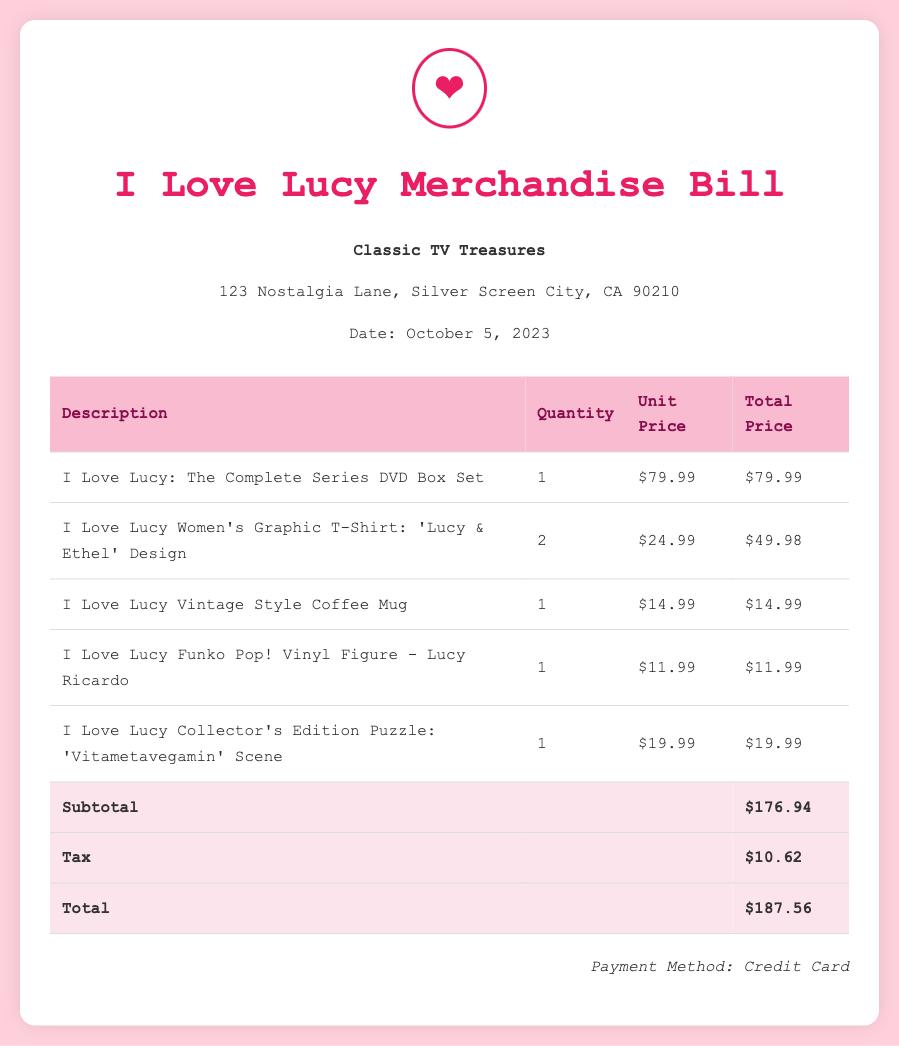What is the name of the store? The name of the store is displayed prominently in the document, suggesting its identity as a merchandise provider.
Answer: Classic TV Treasures What is the date of the bill? The date is indicated in the store information section of the bill.
Answer: October 5, 2023 How many I Love Lucy T-shirts were purchased? The quantity of T-shirts purchased is specified in the merchandise list.
Answer: 2 What is the unit price of the coffee mug? The unit price is detailed next to the coffee mug in the itemized list.
Answer: $14.99 What is the total cost after tax? The total cost after tax is found in the total row of the document.
Answer: $187.56 What item features the 'Vitametavegamin' scene? This specific item is mentioned in the description of one of the collectibles on the bill.
Answer: Collector's Edition Puzzle What is the subtotal before tax? The subtotal is calculated and displayed before the tax in the document.
Answer: $176.94 Which payment method was used? The payment method is usually listed at the end of bills, indicating how it was settled.
Answer: Credit Card 